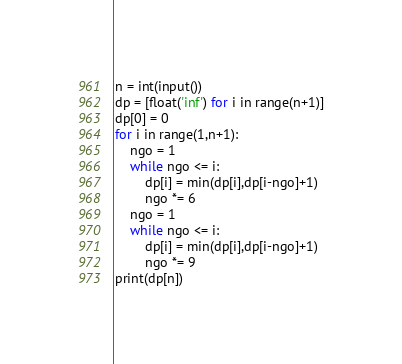Convert code to text. <code><loc_0><loc_0><loc_500><loc_500><_Python_>n = int(input())
dp = [float('inf') for i in range(n+1)]
dp[0] = 0
for i in range(1,n+1):
    ngo = 1
    while ngo <= i:
        dp[i] = min(dp[i],dp[i-ngo]+1)
        ngo *= 6
    ngo = 1
    while ngo <= i:
        dp[i] = min(dp[i],dp[i-ngo]+1)
        ngo *= 9
print(dp[n])</code> 